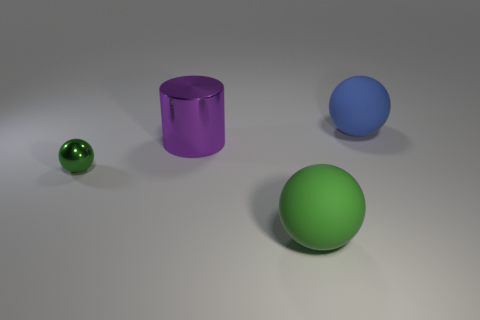Add 3 blue objects. How many objects exist? 7 Subtract all small green balls. How many balls are left? 2 Subtract all purple blocks. How many green spheres are left? 2 Subtract 1 balls. How many balls are left? 2 Subtract all spheres. How many objects are left? 1 Subtract all gray balls. Subtract all brown cylinders. How many balls are left? 3 Add 2 big cyan spheres. How many big cyan spheres exist? 2 Subtract 0 cyan cylinders. How many objects are left? 4 Subtract all purple cylinders. Subtract all tiny green balls. How many objects are left? 2 Add 4 small spheres. How many small spheres are left? 5 